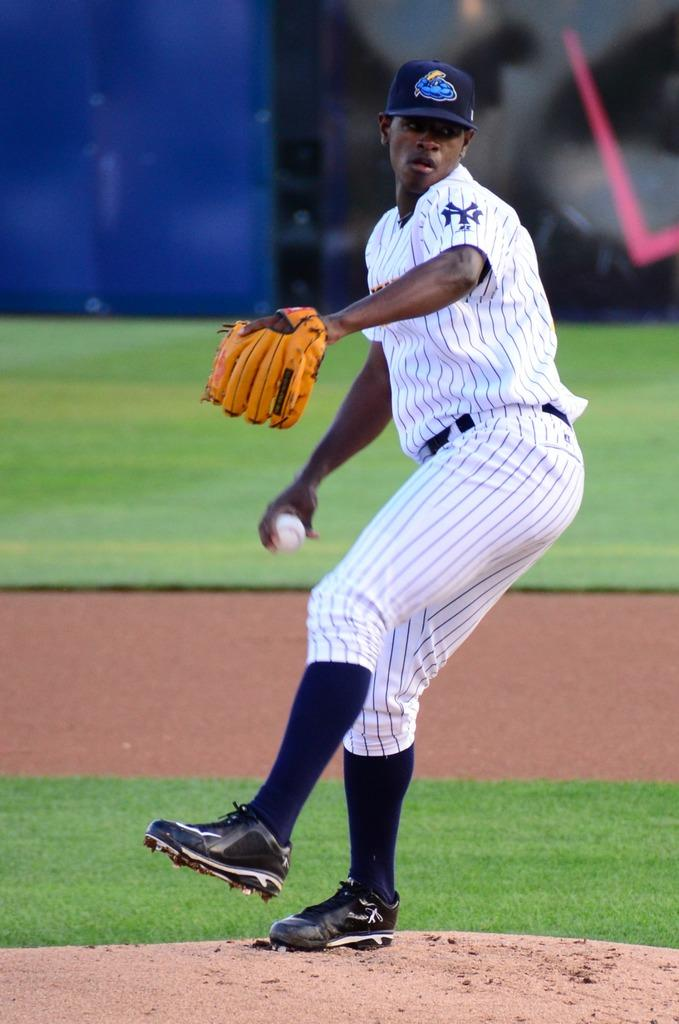<image>
Write a terse but informative summary of the picture. a NY Yankees baseball pitcher ready to throw a ball. 